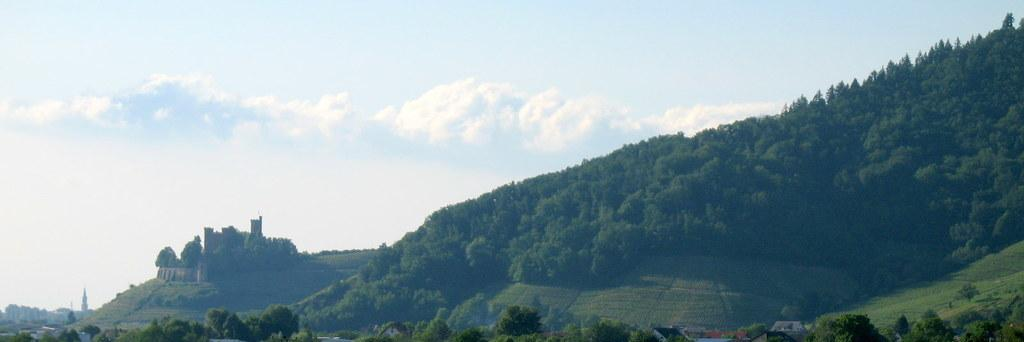What type of natural features can be seen in the image? There are trees and mountains in the image. What is visible in the sky in the image? Clouds are visible in the sky. Are there any man-made structures in the image? Yes, there is a building in the image. What type of finger can be seen in the image? There are no fingers present in the image. 